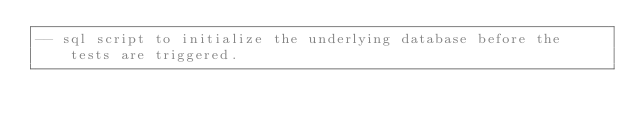Convert code to text. <code><loc_0><loc_0><loc_500><loc_500><_SQL_>-- sql script to initialize the underlying database before the tests are triggered.
</code> 